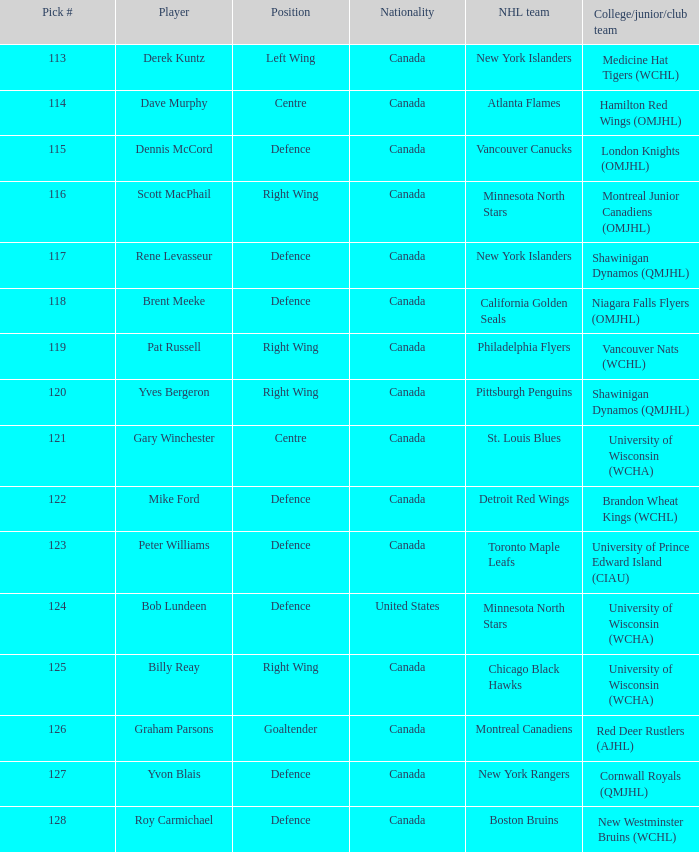Name the player for chicago black hawks Billy Reay. 